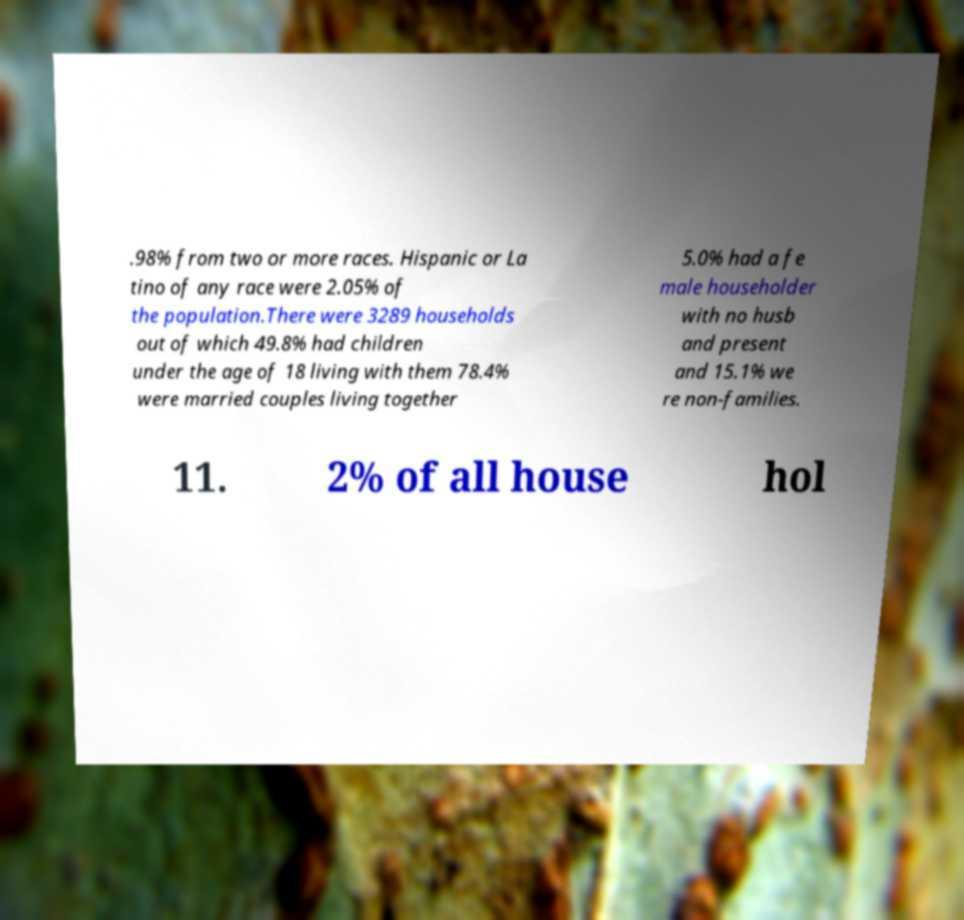There's text embedded in this image that I need extracted. Can you transcribe it verbatim? .98% from two or more races. Hispanic or La tino of any race were 2.05% of the population.There were 3289 households out of which 49.8% had children under the age of 18 living with them 78.4% were married couples living together 5.0% had a fe male householder with no husb and present and 15.1% we re non-families. 11. 2% of all house hol 